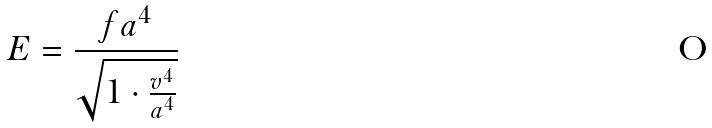<formula> <loc_0><loc_0><loc_500><loc_500>E = \frac { f a ^ { 4 } } { \sqrt { 1 \cdot \frac { v ^ { 4 } } { a ^ { 4 } } } }</formula> 